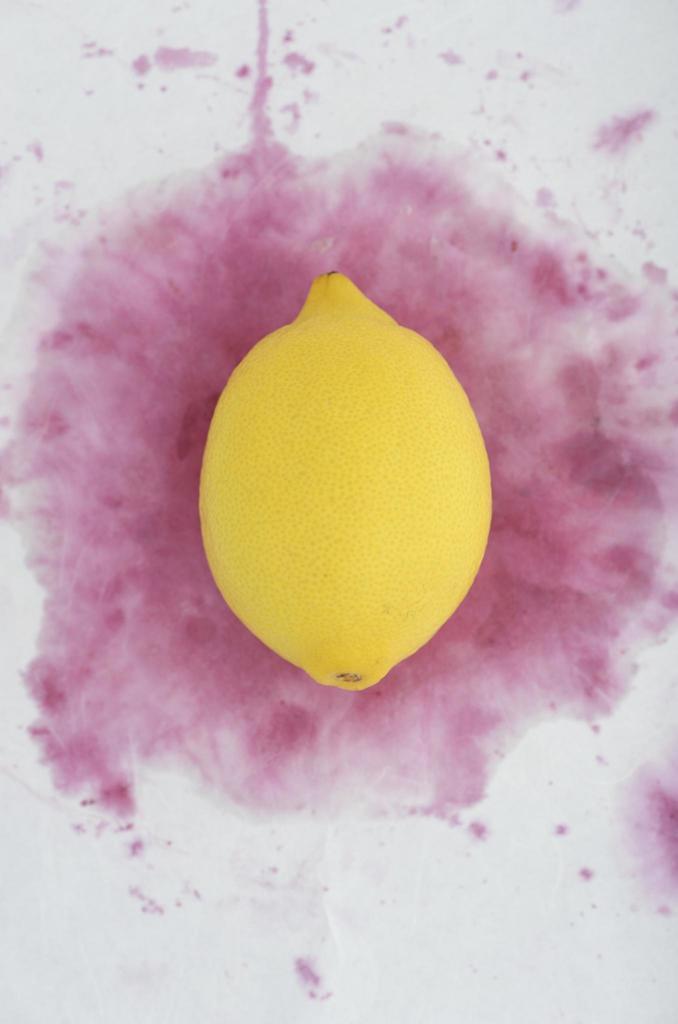Can you describe this image briefly? In this image I can see a lemon which is yellow in color and I can see the white and pink colored surface in the background. 